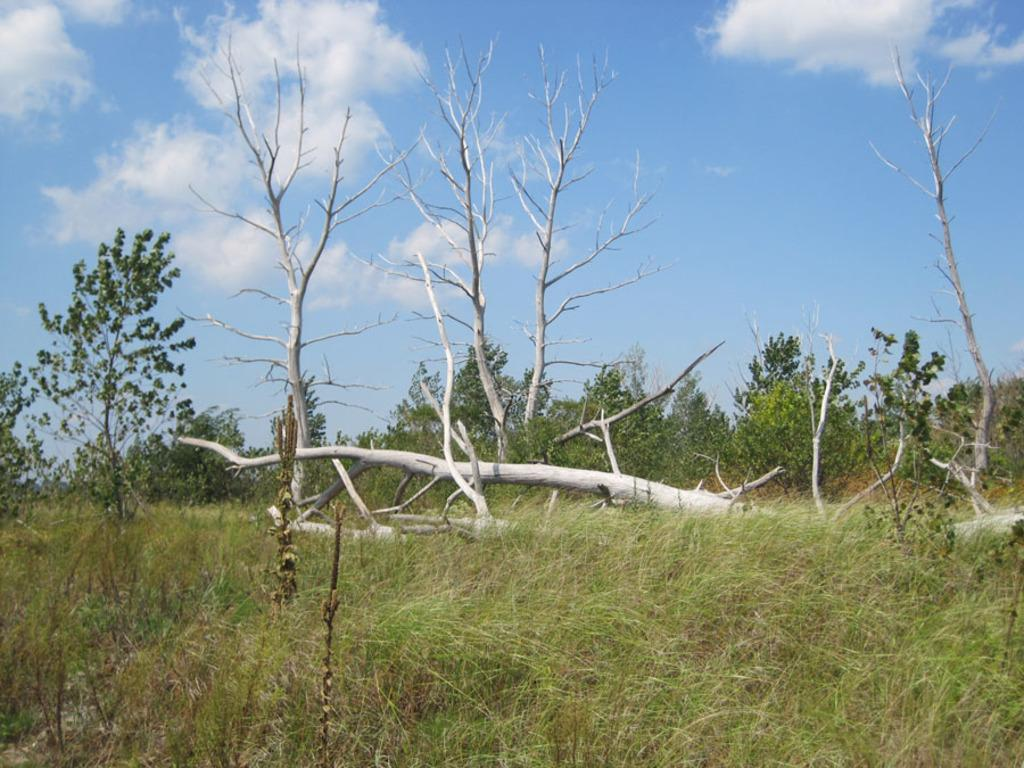What type of vegetation or plants can be seen in the center of the image? There is greenery in the center of the image. What part of the natural environment is visible in the image? The sky is visible at the top side of the image. What type of knowledge can be gained from the root of the plant in the image? There is no root of a plant visible in the image, and therefore no knowledge can be gained from it. 